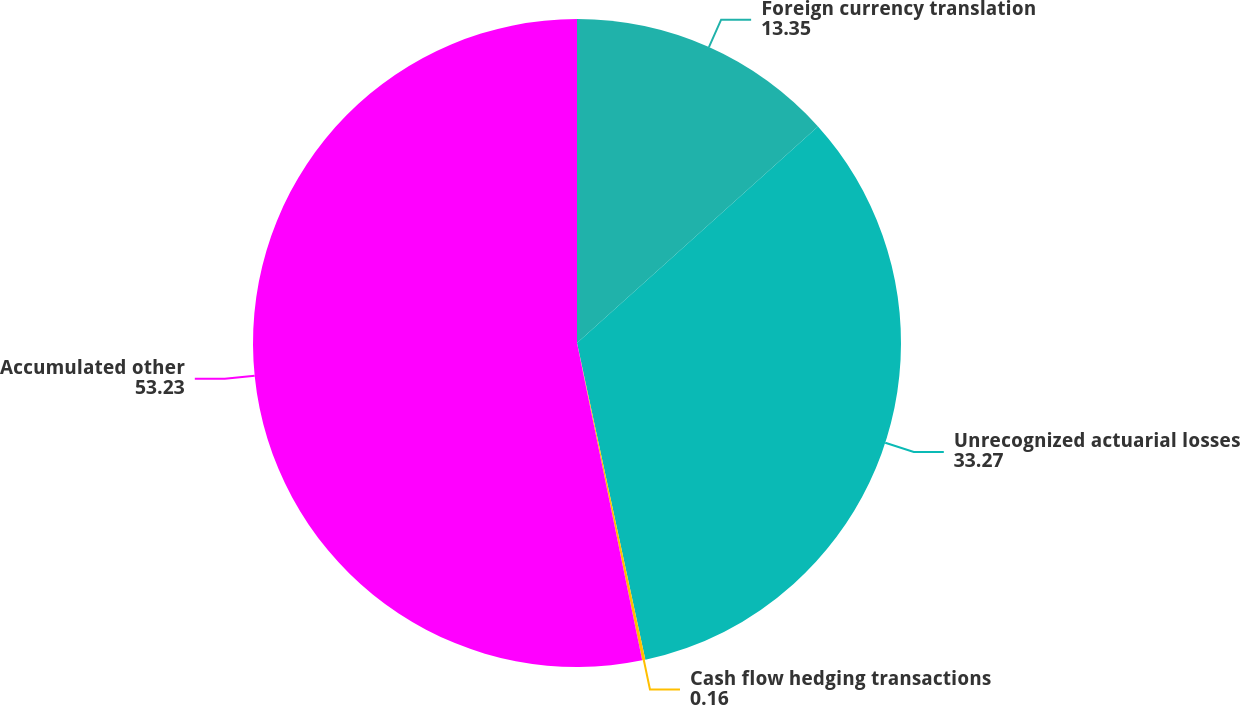Convert chart. <chart><loc_0><loc_0><loc_500><loc_500><pie_chart><fcel>Foreign currency translation<fcel>Unrecognized actuarial losses<fcel>Cash flow hedging transactions<fcel>Accumulated other<nl><fcel>13.35%<fcel>33.27%<fcel>0.16%<fcel>53.23%<nl></chart> 